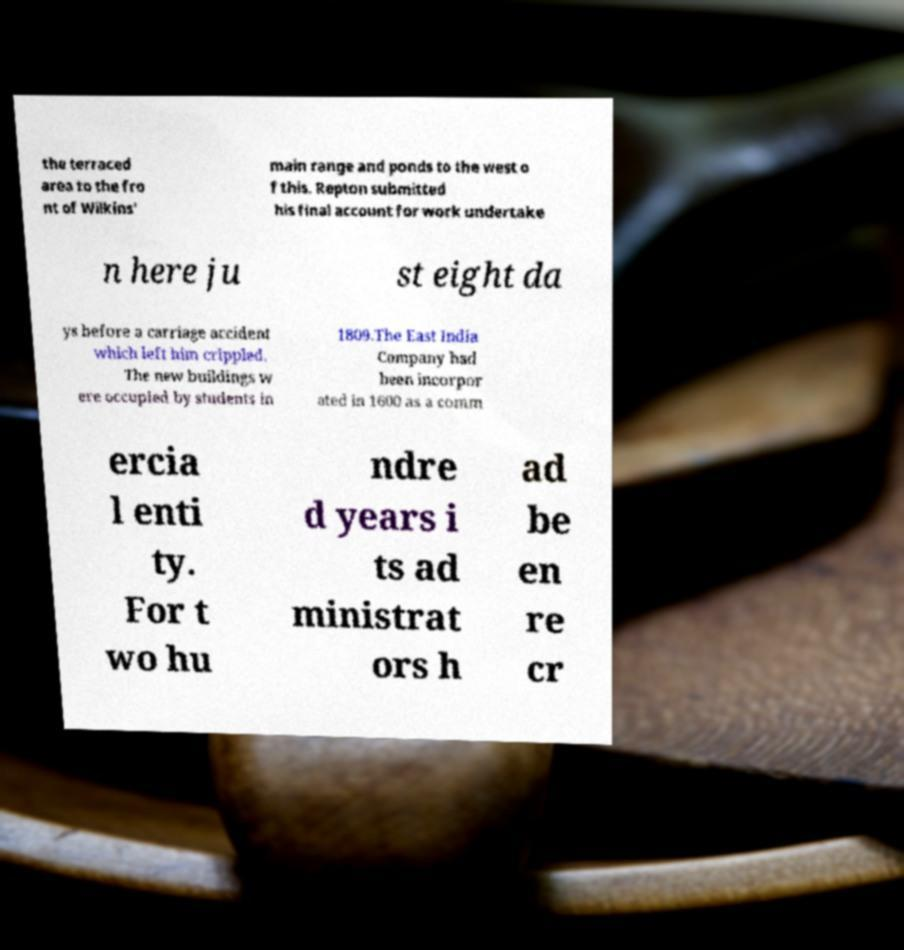There's text embedded in this image that I need extracted. Can you transcribe it verbatim? the terraced area to the fro nt of Wilkins' main range and ponds to the west o f this. Repton submitted his final account for work undertake n here ju st eight da ys before a carriage accident which left him crippled. The new buildings w ere occupied by students in 1809.The East India Company had been incorpor ated in 1600 as a comm ercia l enti ty. For t wo hu ndre d years i ts ad ministrat ors h ad be en re cr 